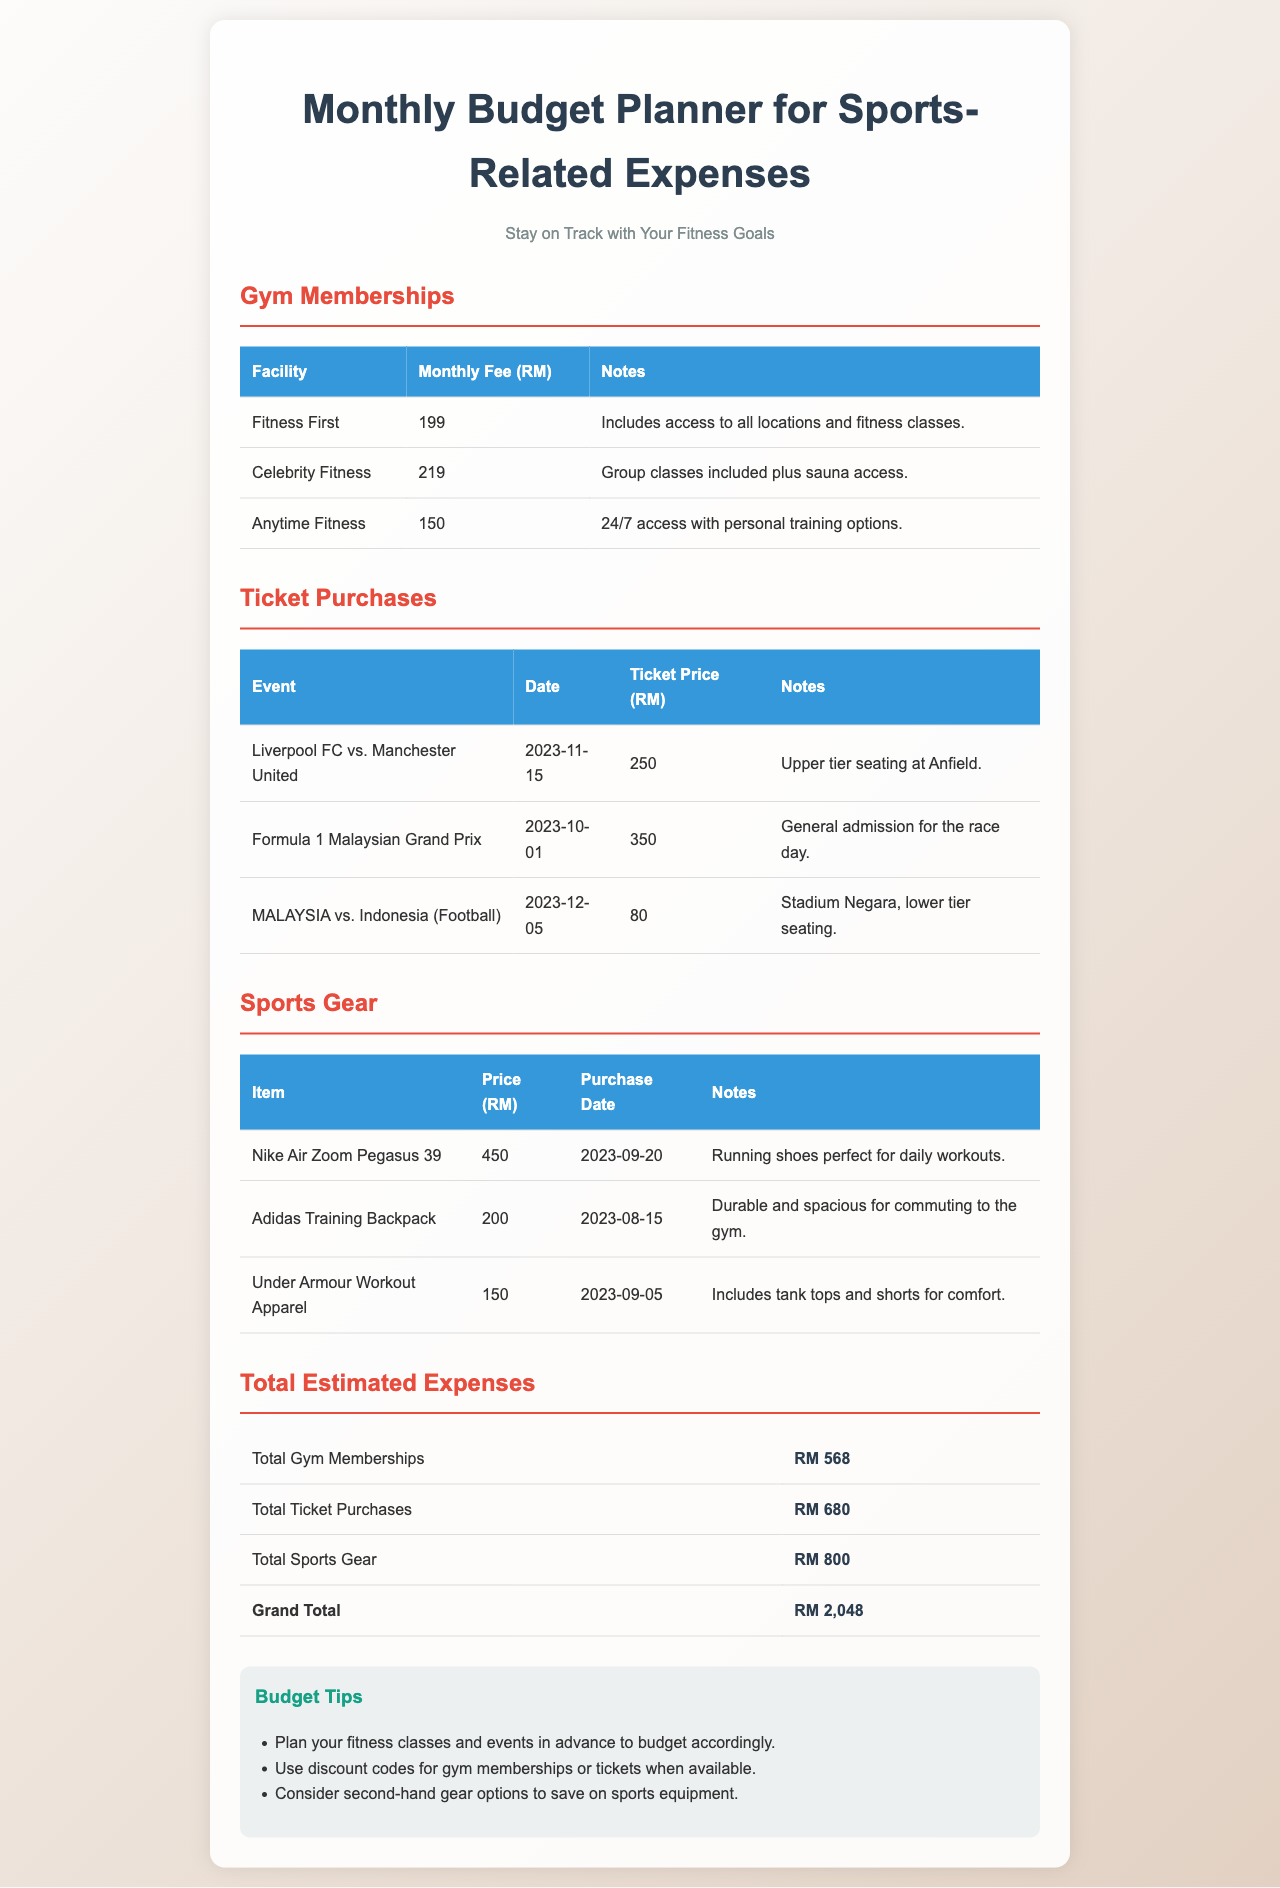What is the monthly fee for Fitness First? The monthly fee listed for Fitness First in the document is RM 199.
Answer: RM 199 What is the total cost for the ticket to Liverpool FC vs. Manchester United? The ticket price for the event is specified as RM 250 in the document.
Answer: RM 250 How much did the Nike Air Zoom Pegasus 39 cost? The document indicates that the price of the Nike Air Zoom Pegasus 39 is RM 450.
Answer: RM 450 What is the Grand Total of estimated expenses? The Grand Total is calculated as the sum of all expenses listed in the document, which comes out to RM 2,048.
Answer: RM 2,048 How many gym memberships are listed in the document? There are three gym memberships mentioned in the document: Fitness First, Celebrity Fitness, and Anytime Fitness.
Answer: 3 What is the date of the Formula 1 Malaysian Grand Prix? The date for the Formula 1 Malaysian Grand Prix is stated as 2023-10-01 in the document.
Answer: 2023-10-01 Which sports gear is listed as being purchased on September 20, 2023? The document mentions that the Nike Air Zoom Pegasus 39 was purchased on September 20, 2023.
Answer: Nike Air Zoom Pegasus 39 What tip is provided regarding gym memberships or tickets? A tip suggests using discount codes for gym memberships or tickets when available, as listed in the document.
Answer: Use discount codes What is the price of the sports gear Under Armour Workout Apparel? The price for Under Armour Workout Apparel is specified as RM 150 in the document.
Answer: RM 150 What is the total amount spent on ticket purchases? The document specifies the total amount for ticket purchases as RM 680.
Answer: RM 680 